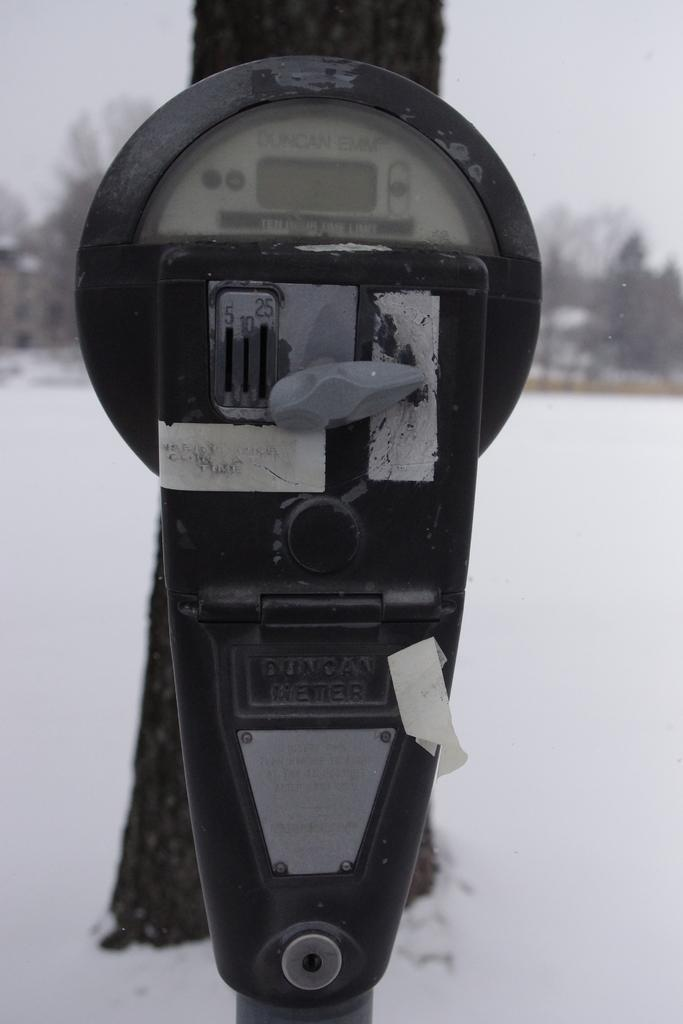<image>
Write a terse but informative summary of the picture. A parking meter is branded as "Duncan Emm" 